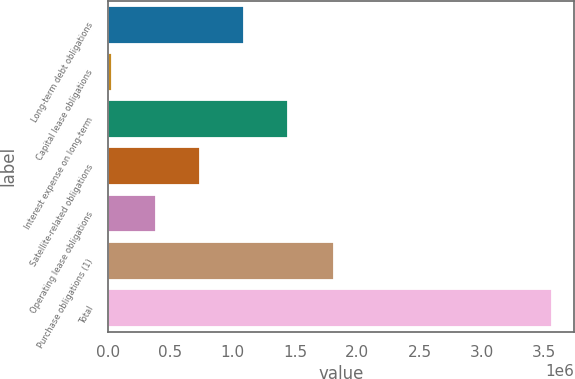Convert chart. <chart><loc_0><loc_0><loc_500><loc_500><bar_chart><fcel>Long-term debt obligations<fcel>Capital lease obligations<fcel>Interest expense on long-term<fcel>Satellite-related obligations<fcel>Operating lease obligations<fcel>Purchase obligations (1)<fcel>Total<nl><fcel>1.08958e+06<fcel>29515<fcel>1.44294e+06<fcel>736227<fcel>382871<fcel>1.81036e+06<fcel>3.56307e+06<nl></chart> 